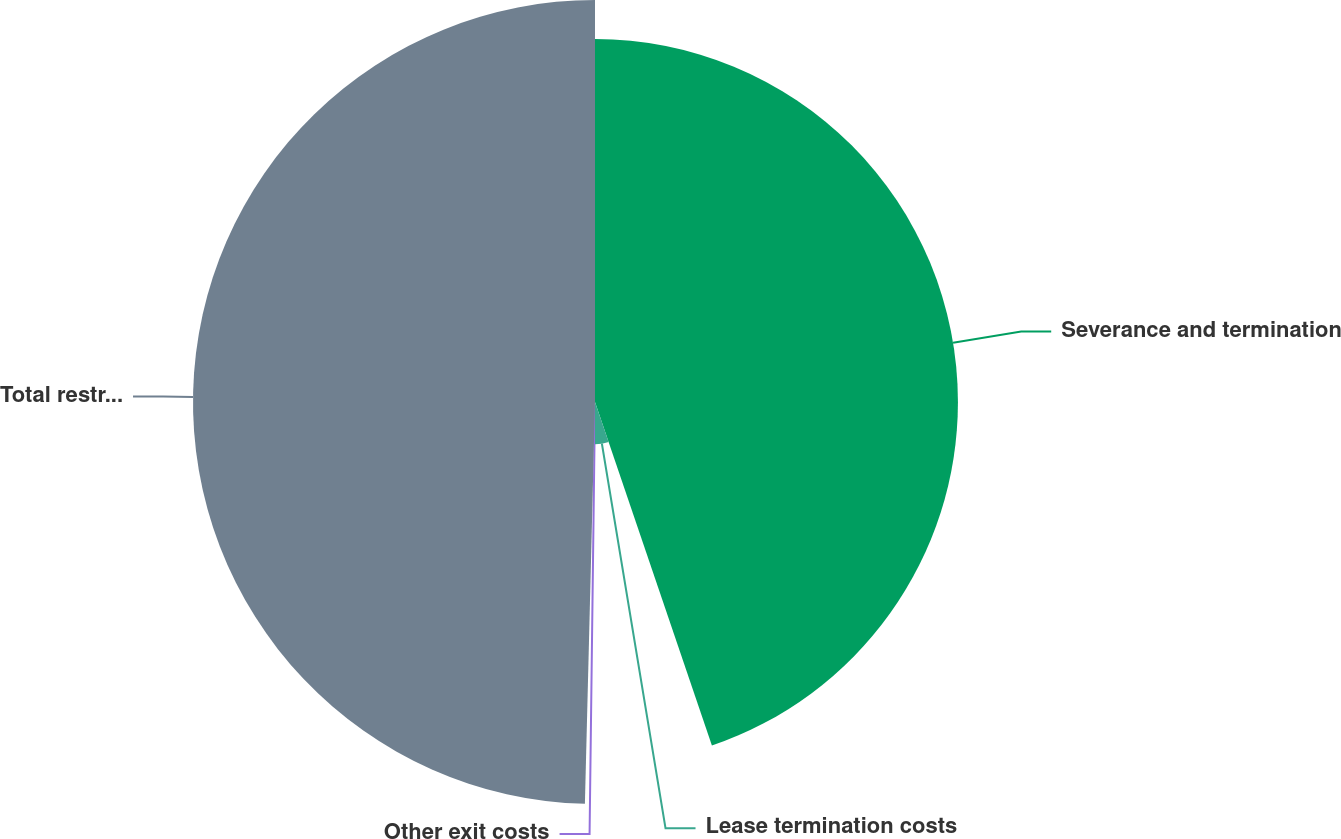Convert chart to OTSL. <chart><loc_0><loc_0><loc_500><loc_500><pie_chart><fcel>Severance and termination<fcel>Lease termination costs<fcel>Other exit costs<fcel>Total restructuring and other<nl><fcel>44.78%<fcel>5.22%<fcel>0.4%<fcel>49.6%<nl></chart> 